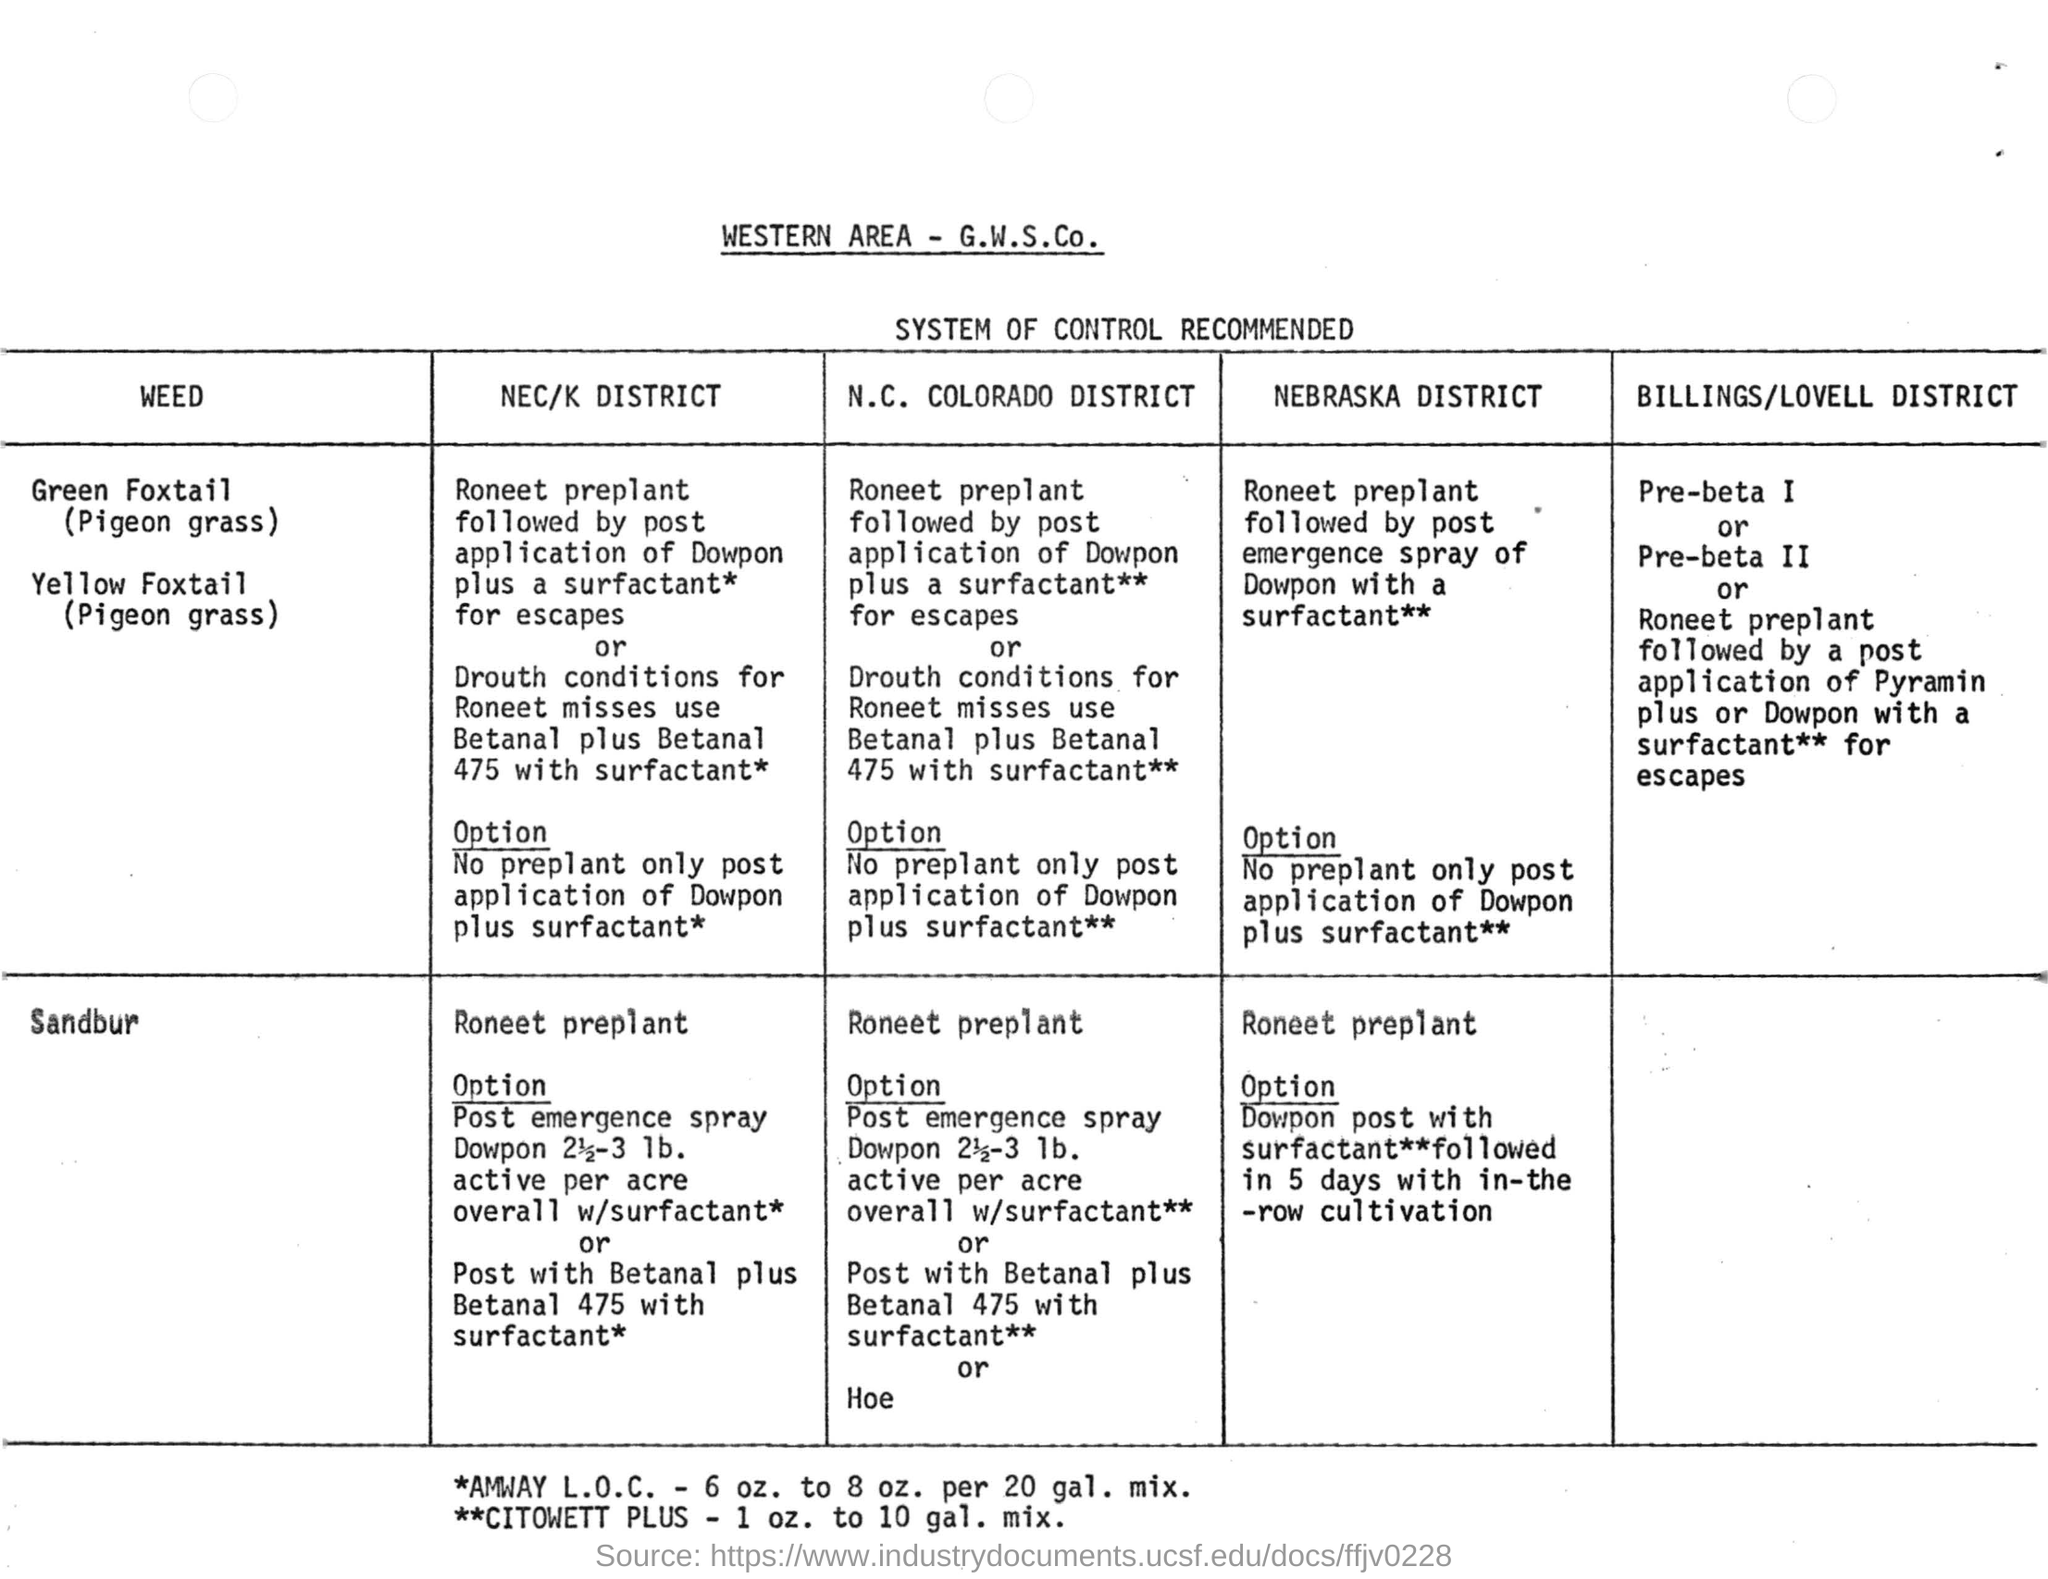Indicate a few pertinent items in this graphic. The document is titled "Western Area - G.W.S.Co." and the heading provides important information about the document's focus and content. The table heading is 'SYSTEM OF CONTROL RECOMMENDED.' 